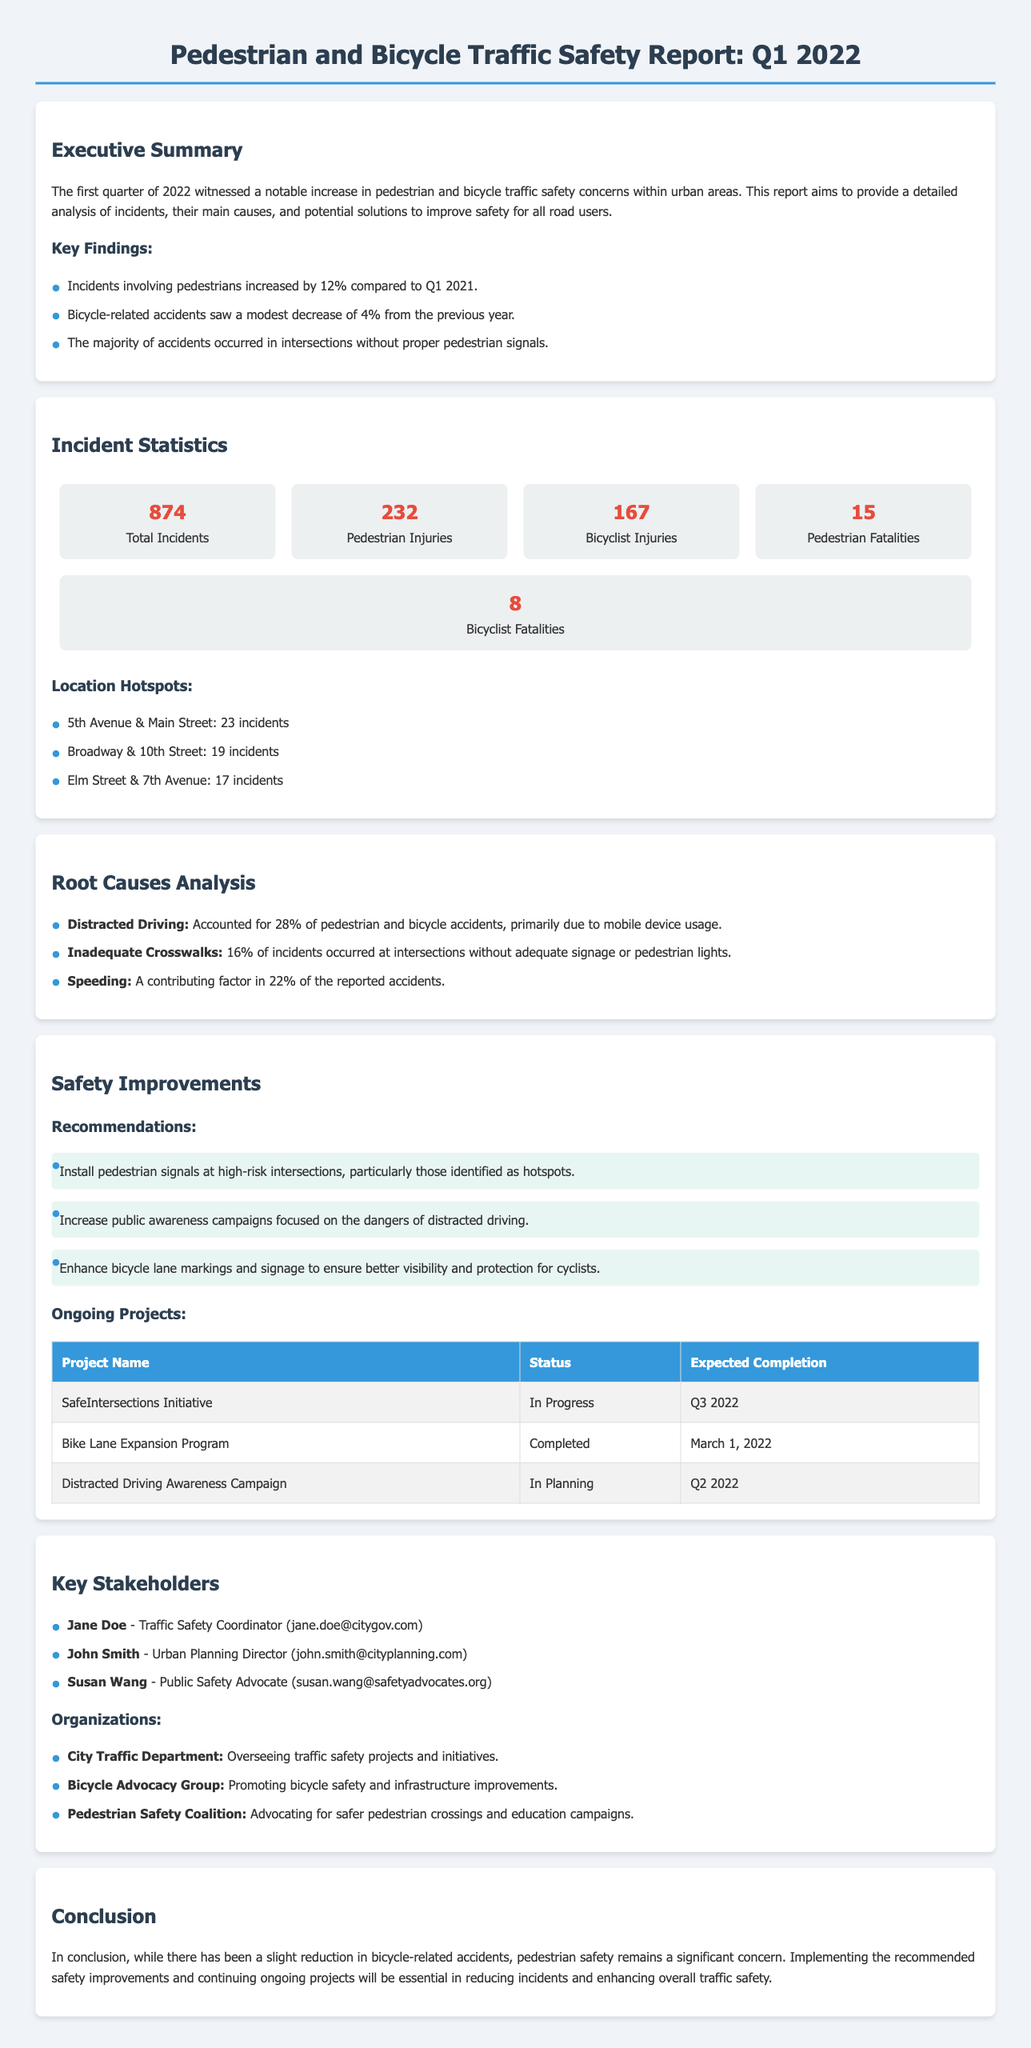What percentage increase in pedestrian incidents was reported? The report states that incidents involving pedestrians increased by 12% compared to Q1 2021.
Answer: 12% How many total incidents were recorded in Q1 2022? The total number of incidents recorded in the report for Q1 2022 is explicitly stated as 874.
Answer: 874 What were the pedestrian fatalities reported in this quarter? The report indicates that there were 15 pedestrian fatalities during Q1 2022.
Answer: 15 Which intersection had the highest number of incidents? The document lists that 5th Avenue & Main Street had the highest incidents with 23 occurrences.
Answer: 5th Avenue & Main Street What is the status of the SafeIntersections Initiative? The document provides the status of the SafeIntersections Initiative, which is currently "In Progress".
Answer: In Progress Which root cause accounted for the highest percentage of accidents? According to the report, distracted driving accounted for the highest percentage at 28%.
Answer: 28% Name one ongoing project mentioned in the report. The report lists three ongoing projects. One of them is the "Bike Lane Expansion Program".
Answer: Bike Lane Expansion Program What is the expected completion date for the Distracted Driving Awareness Campaign? The report mentions that the expected completion for this campaign is Q2 2022.
Answer: Q2 2022 Who is the Traffic Safety Coordinator listed as a key stakeholder? The document identifies Jane Doe as the Traffic Safety Coordinator.
Answer: Jane Doe 